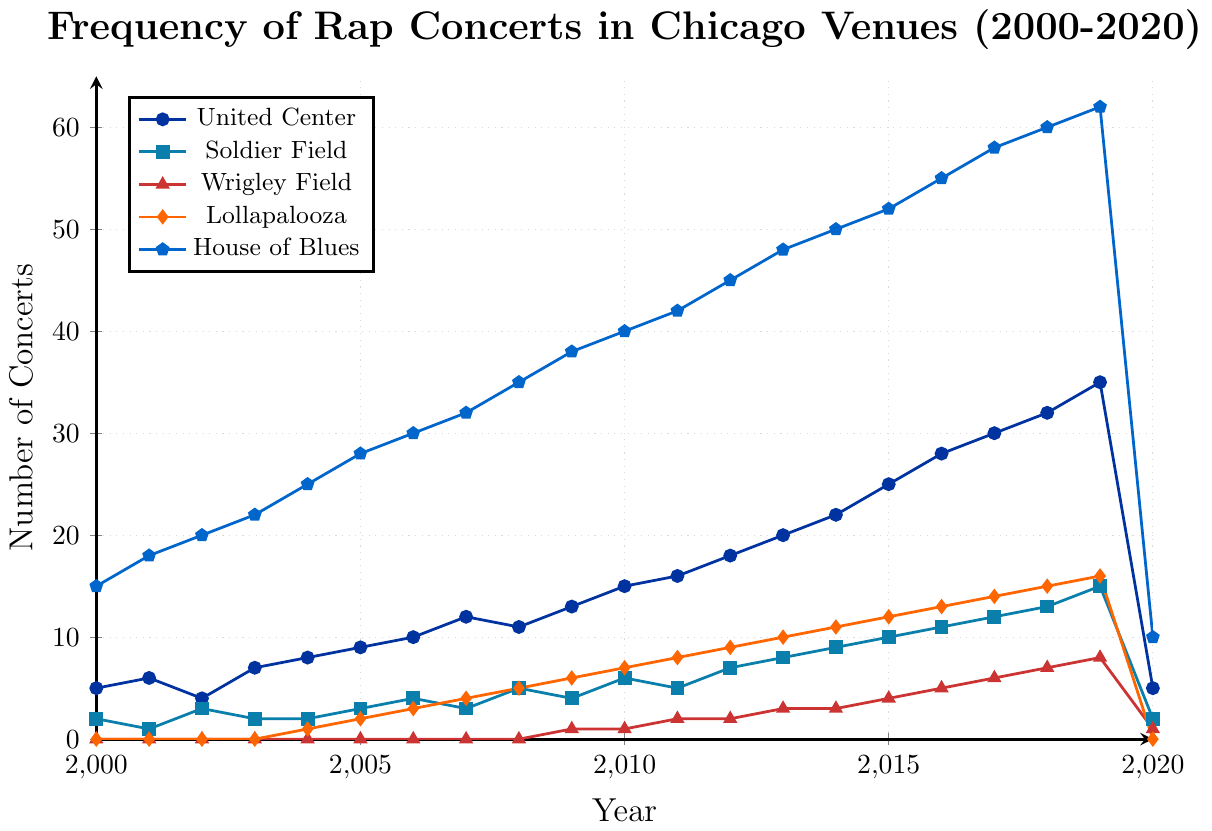Which venue had the highest number of rap concerts in 2020? By looking at the year 2020 on the x-axis and finding the highest point on the y-axis among the lines, we see that House of Blues had the highest number of concerts with a value of 10.
Answer: House of Blues In 2019, how many more concerts were held at Soldier Field compared to Wrigley Field? In 2019, Soldier Field had 15 concerts and Wrigley Field had 8 concerts. The difference is 15 - 8 = 7.
Answer: 7 What year did Lollapalooza first appear as a venue for rap concerts? By checking the Lollapalooza line, we can see it starts from 2004 with 1 concert.
Answer: 2004 Which venue saw the steepest drop in the number of concerts in 2020 compared to 2019? Comparing the lines from 2019 to 2020, the United Center dropped from 35 to 5, a drop of 30, which is the steepest.
Answer: United Center Between 2010 and 2015, which venue showed consistent growth in the number of rap concerts every year? Checking each venue's trend from 2010 to 2015, House of Blues showed consistent growth each year from 40 to 52 concerts.
Answer: House of Blues Which venue had the highest temporary peak in rap concert frequency within the time period 2000-2020, excluding the year 2020? Excluding 2020 and looking for the highest peak overall, House of Blues had the highest peak in 2019 with 62 concerts.
Answer: House of Blues By what amount did the number of concerts at United Center change from 2018 to 2019? From the figure, United Center had 32 concerts in 2018 and 35 concerts in 2019. The change is 35 - 32 = 3.
Answer: 3 On average, how many concerts per year were held at Wrigley Field between 2009 and 2019? Summing the concerts from 2009 to 2019: 1 + 1 + 2 + 2 + 3 + 3 + 4 + 5 + 6 + 7 + 8 = 42. There are 11 years, so the average is 42 / 11 ≈ 3.82.
Answer: 3.82 In what year did Soldier Field have exactly 6 rap concerts? Looking at the Soldier Field line, the point where it reaches 6 concerts is in the year 2010.
Answer: 2010 How many total rap concerts were held across all venues in 2015? Summing the values for 2015: 25 (United Center) + 10 (Soldier Field) + 4 (Wrigley Field) + 12 (Lollapalooza) + 52 (House of Blues) = 103 concerts.
Answer: 103 